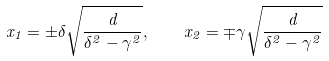Convert formula to latex. <formula><loc_0><loc_0><loc_500><loc_500>x _ { 1 } = \pm \delta \sqrt { \frac { d } { \delta ^ { 2 } - \gamma ^ { 2 } } } , \quad x _ { 2 } = \mp \gamma \sqrt { \frac { d } { \delta ^ { 2 } - \gamma ^ { 2 } } }</formula> 